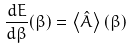Convert formula to latex. <formula><loc_0><loc_0><loc_500><loc_500>\frac { d E } { d \beta } ( \beta ) = \left \langle \hat { A } \right \rangle ( \beta )</formula> 